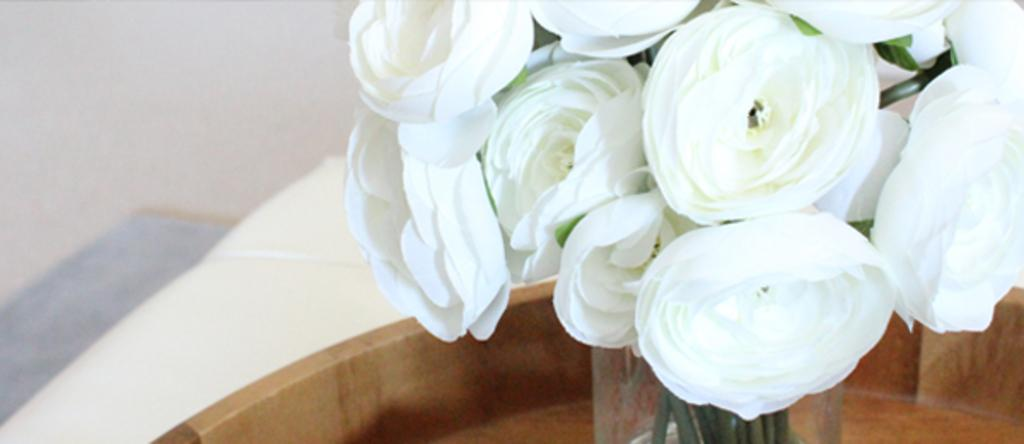What type of flowers are in the wooden bowl in the image? There are white flowers in a wooden bowl in the image. What material is the bowl made of? The bowl is made of wood. What can be seen on the left side of the image? The floor is visible on the left side of the image. What type of camera can be seen in the image? There is no camera present in the image. What type of leather material is visible in the image? There is no leather material present in the image. What type of songs can be heard playing in the background of the image? There is no audio or indication of songs in the image. 